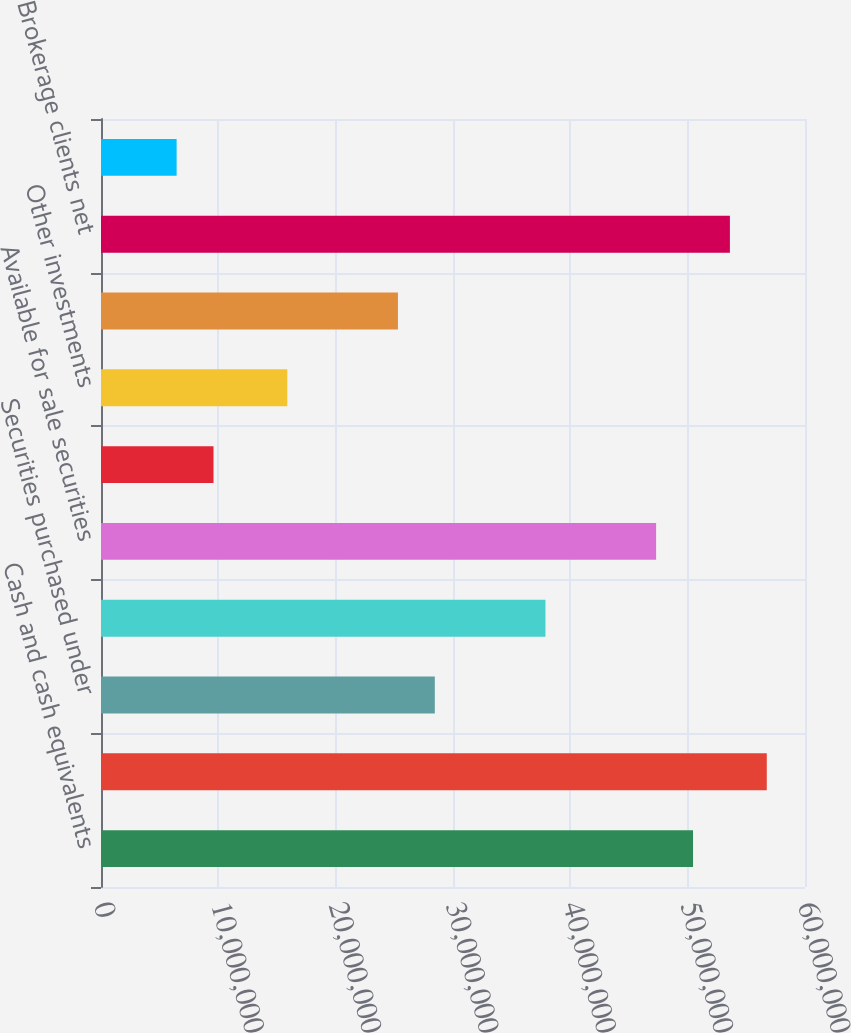Convert chart. <chart><loc_0><loc_0><loc_500><loc_500><bar_chart><fcel>Cash and cash equivalents<fcel>Assets segregated pursuant to<fcel>Securities purchased under<fcel>Trading instruments<fcel>Available for sale securities<fcel>Private equity investments<fcel>Other investments<fcel>Derivative instruments<fcel>Brokerage clients net<fcel>Stock borrowed<nl><fcel>5.04556e+07<fcel>5.67429e+07<fcel>2.84501e+07<fcel>3.7881e+07<fcel>4.7312e+07<fcel>9.58818e+06<fcel>1.58755e+07<fcel>2.53064e+07<fcel>5.35993e+07<fcel>6.44453e+06<nl></chart> 